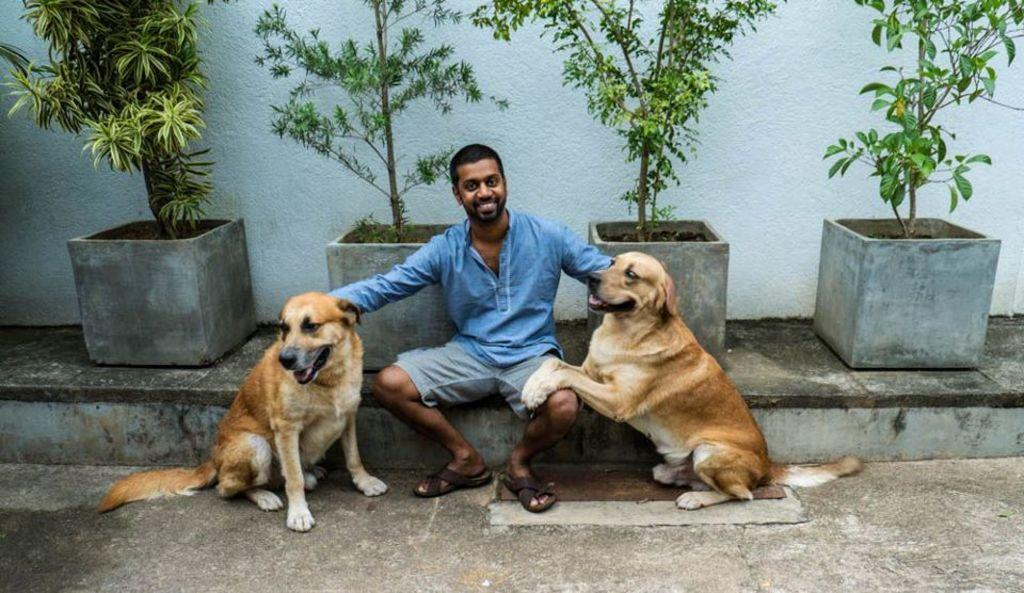What is the person in the image doing? The person is sitting on the floor. What is the person holding in their hand? The person is holding dogs in their hand. What can be seen in the background of the image? There are trees and a wall visible in the background. What type of paint is being used by the person in the image? There is no paint present in the image; the person is holding dogs in their hand. 